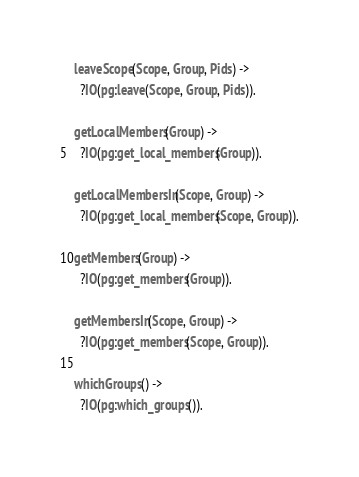Convert code to text. <code><loc_0><loc_0><loc_500><loc_500><_Erlang_>
leaveScope(Scope, Group, Pids) ->
  ?IO(pg:leave(Scope, Group, Pids)).

getLocalMembers(Group) ->
  ?IO(pg:get_local_members(Group)).

getLocalMembersIn(Scope, Group) ->
  ?IO(pg:get_local_members(Scope, Group)).

getMembers(Group) ->
  ?IO(pg:get_members(Group)).

getMembersIn(Scope, Group) ->
  ?IO(pg:get_members(Scope, Group)).

whichGroups() ->
  ?IO(pg:which_groups()).
</code> 